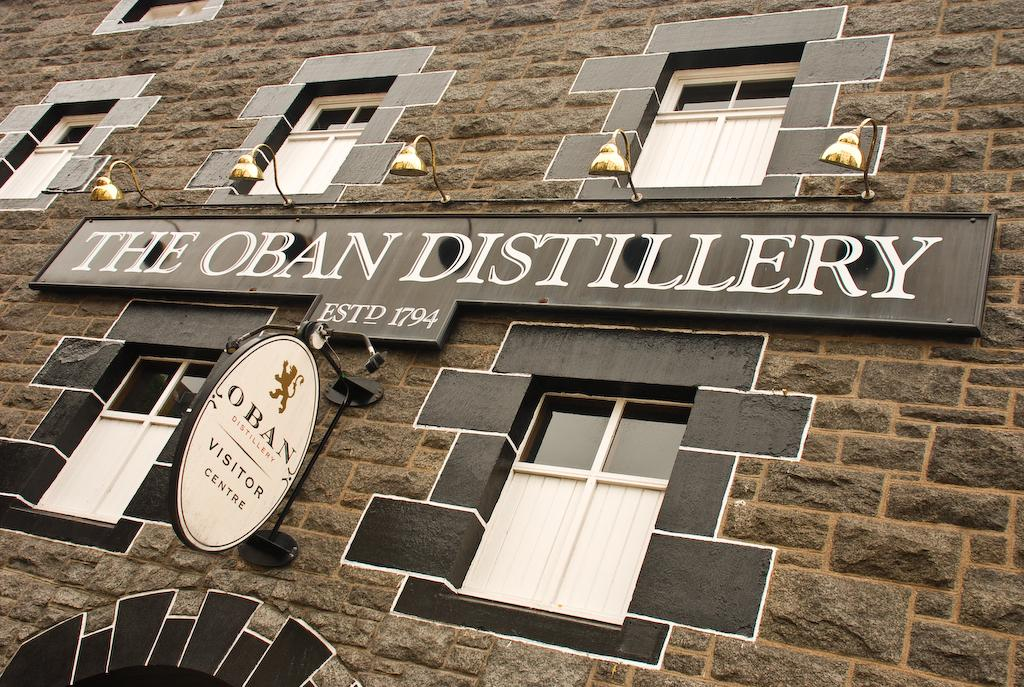What is the main subject of the image? The main subject of the image is a building. Can you describe the building in the image? The building is in the center of the image and has windows. Are there any additional features on the building? Yes, there are posters on the building. What type of ear is visible on the building in the image? There is no ear present on the building in the image. Can you tell me how many flights are taking off from the building in the image? There are no flights or airplanes present in the image; it features a building with posters. 